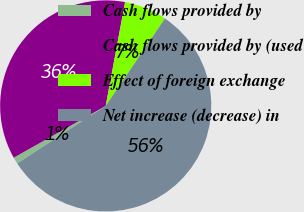Convert chart to OTSL. <chart><loc_0><loc_0><loc_500><loc_500><pie_chart><fcel>Cash flows provided by<fcel>Cash flows provided by (used<fcel>Effect of foreign exchange<fcel>Net increase (decrease) in<nl><fcel>1.01%<fcel>36.1%<fcel>6.54%<fcel>56.35%<nl></chart> 